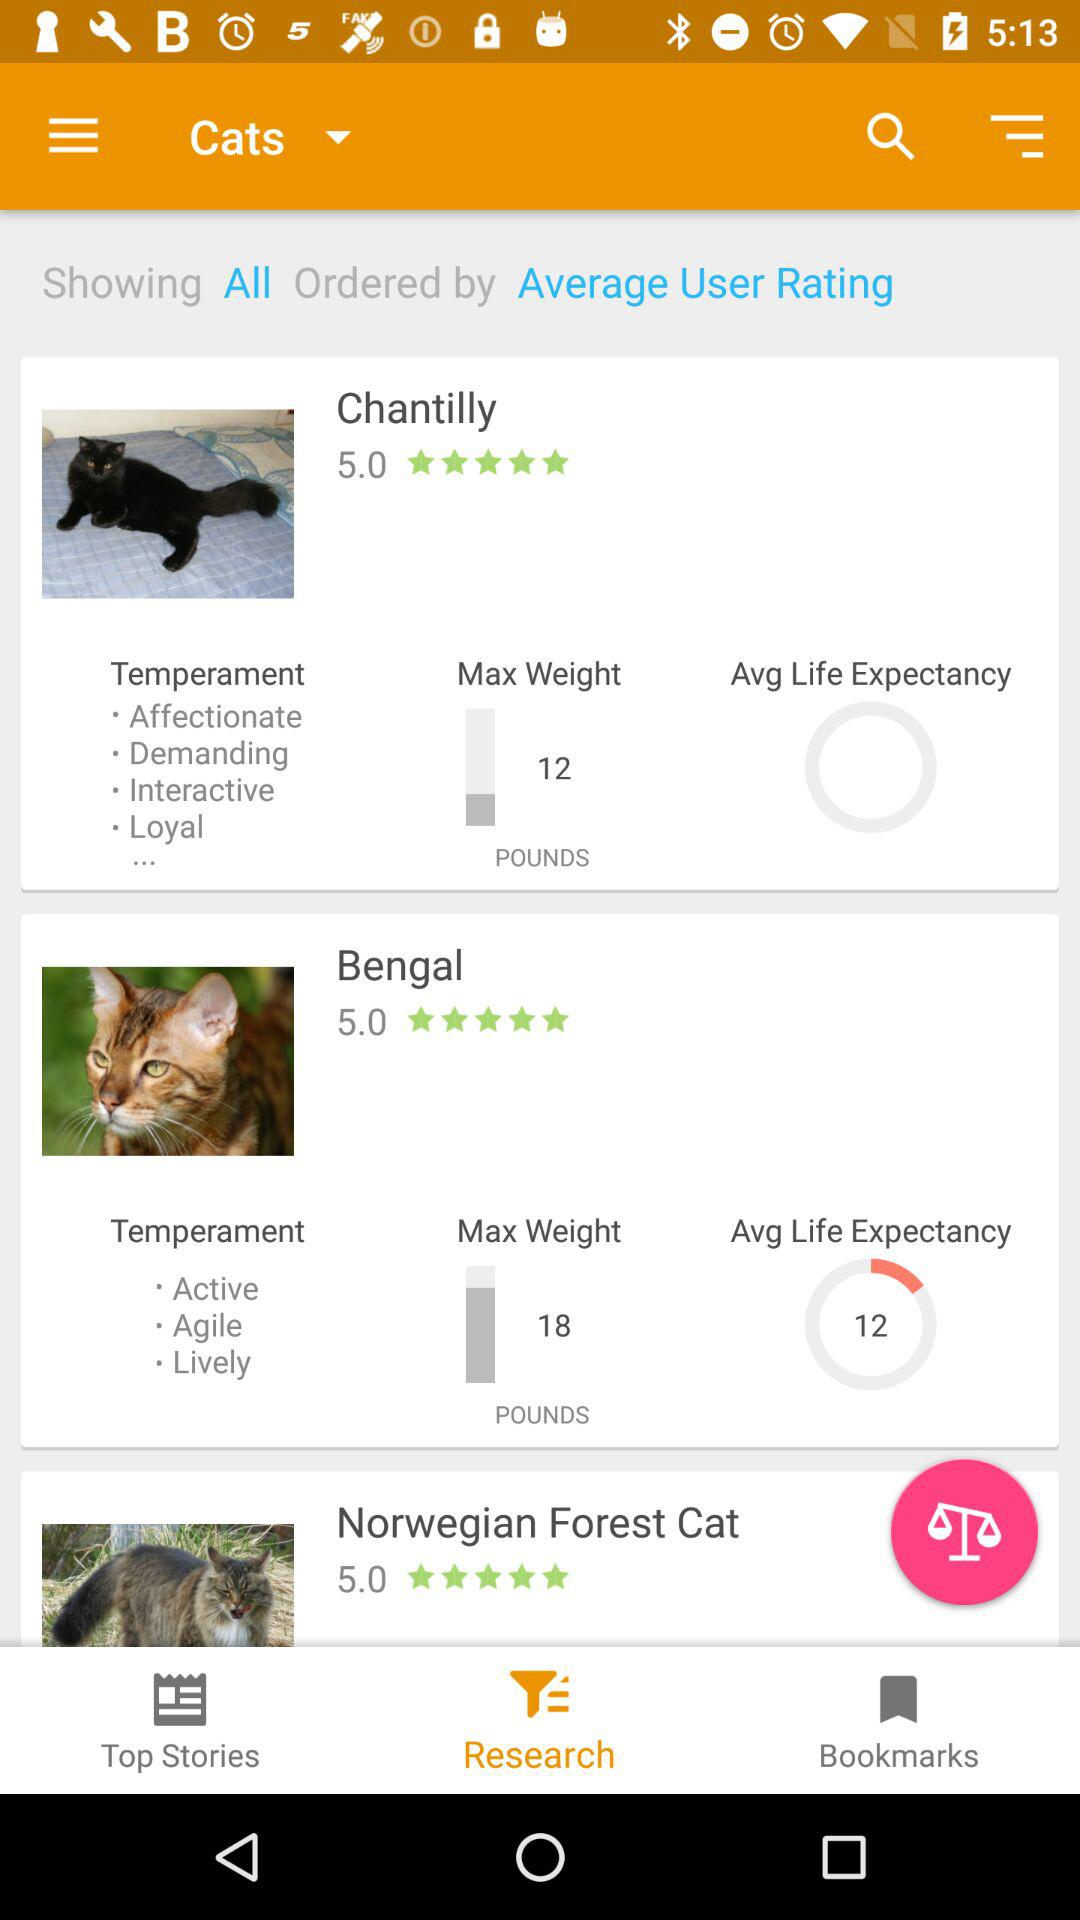What is the maximum weight of Bengal? The maximum weight of Bengal is 18 pounds. 